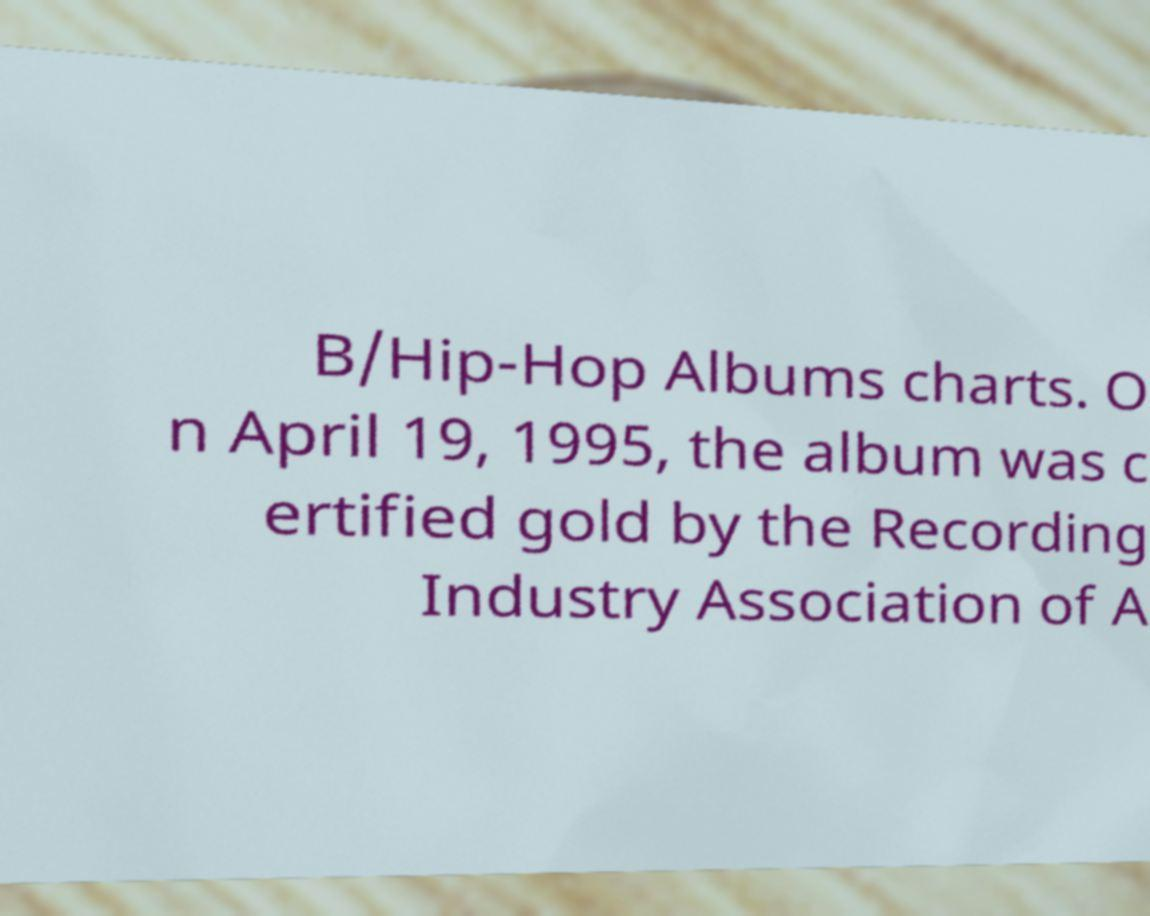Could you assist in decoding the text presented in this image and type it out clearly? B/Hip-Hop Albums charts. O n April 19, 1995, the album was c ertified gold by the Recording Industry Association of A 